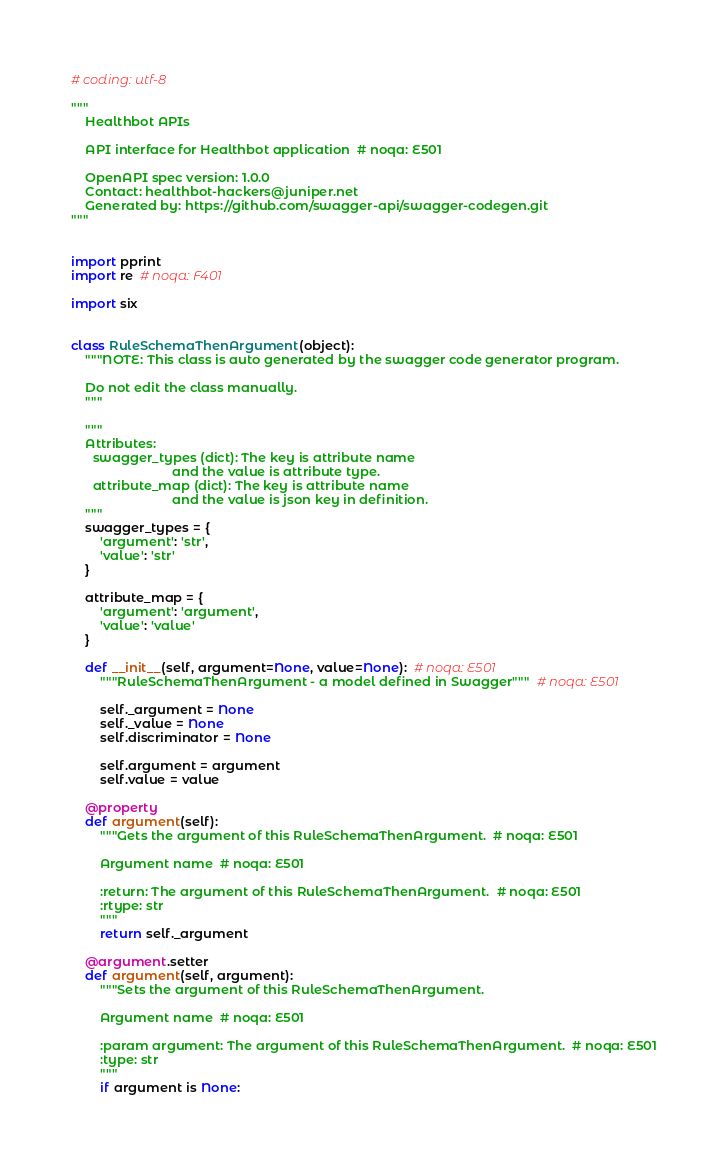Convert code to text. <code><loc_0><loc_0><loc_500><loc_500><_Python_># coding: utf-8

"""
    Healthbot APIs

    API interface for Healthbot application  # noqa: E501

    OpenAPI spec version: 1.0.0
    Contact: healthbot-hackers@juniper.net
    Generated by: https://github.com/swagger-api/swagger-codegen.git
"""


import pprint
import re  # noqa: F401

import six


class RuleSchemaThenArgument(object):
    """NOTE: This class is auto generated by the swagger code generator program.

    Do not edit the class manually.
    """

    """
    Attributes:
      swagger_types (dict): The key is attribute name
                            and the value is attribute type.
      attribute_map (dict): The key is attribute name
                            and the value is json key in definition.
    """
    swagger_types = {
        'argument': 'str',
        'value': 'str'
    }

    attribute_map = {
        'argument': 'argument',
        'value': 'value'
    }

    def __init__(self, argument=None, value=None):  # noqa: E501
        """RuleSchemaThenArgument - a model defined in Swagger"""  # noqa: E501

        self._argument = None
        self._value = None
        self.discriminator = None

        self.argument = argument
        self.value = value

    @property
    def argument(self):
        """Gets the argument of this RuleSchemaThenArgument.  # noqa: E501

        Argument name  # noqa: E501

        :return: The argument of this RuleSchemaThenArgument.  # noqa: E501
        :rtype: str
        """
        return self._argument

    @argument.setter
    def argument(self, argument):
        """Sets the argument of this RuleSchemaThenArgument.

        Argument name  # noqa: E501

        :param argument: The argument of this RuleSchemaThenArgument.  # noqa: E501
        :type: str
        """
        if argument is None:</code> 